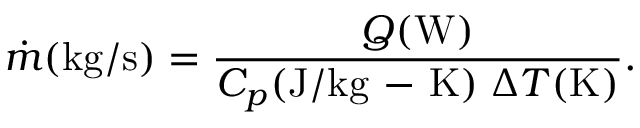Convert formula to latex. <formula><loc_0><loc_0><loc_500><loc_500>\dot { m } ( k g / s ) = \frac { Q ( W ) } { C _ { p } ( J / k g - K ) \, \Delta T ( K ) } .</formula> 